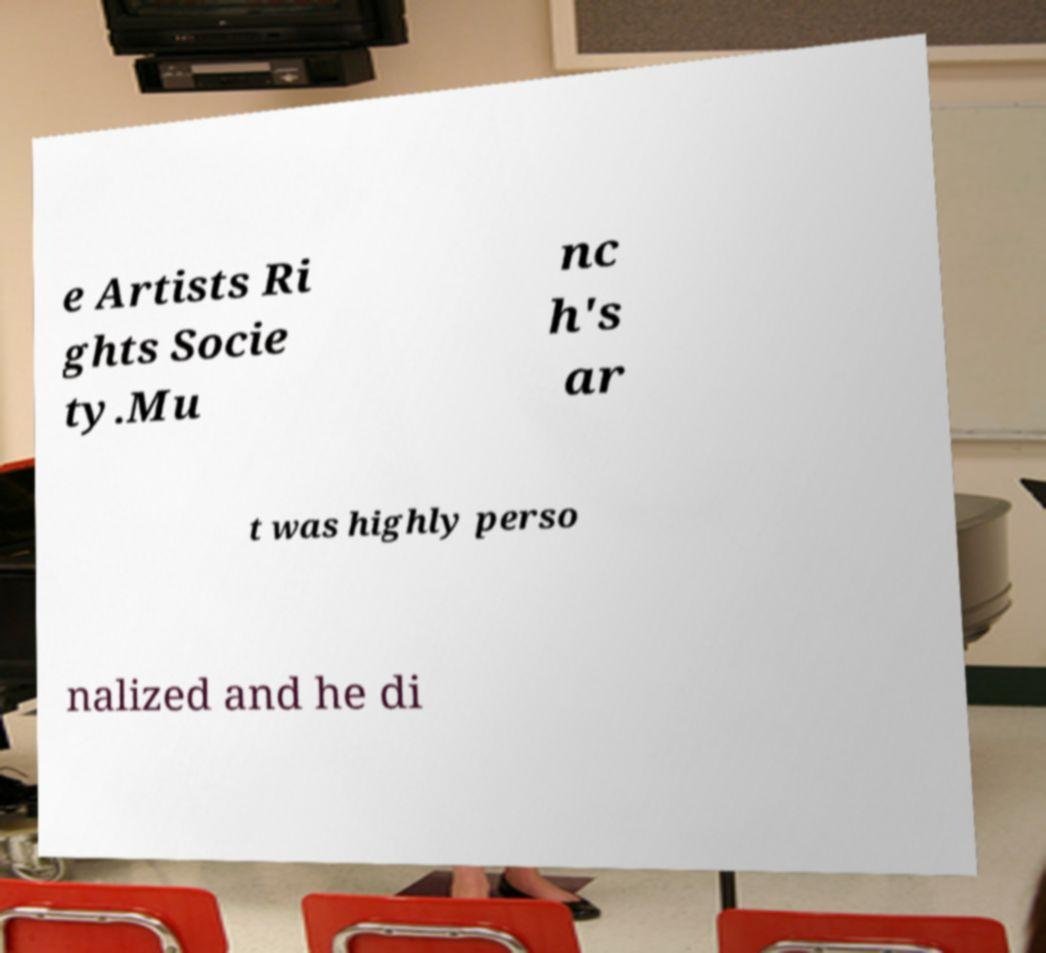Could you extract and type out the text from this image? e Artists Ri ghts Socie ty.Mu nc h's ar t was highly perso nalized and he di 